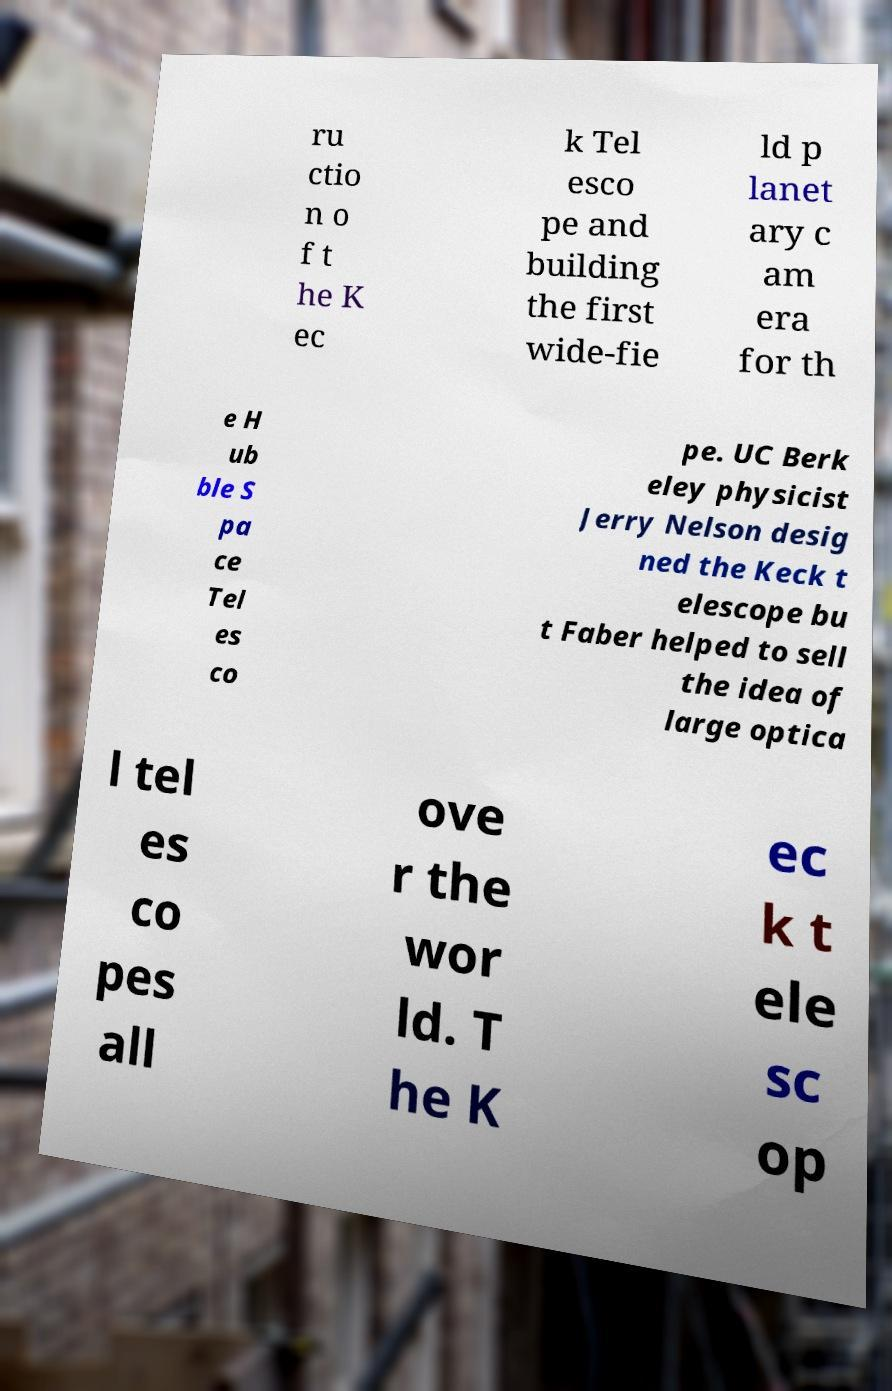I need the written content from this picture converted into text. Can you do that? ru ctio n o f t he K ec k Tel esco pe and building the first wide-fie ld p lanet ary c am era for th e H ub ble S pa ce Tel es co pe. UC Berk eley physicist Jerry Nelson desig ned the Keck t elescope bu t Faber helped to sell the idea of large optica l tel es co pes all ove r the wor ld. T he K ec k t ele sc op 